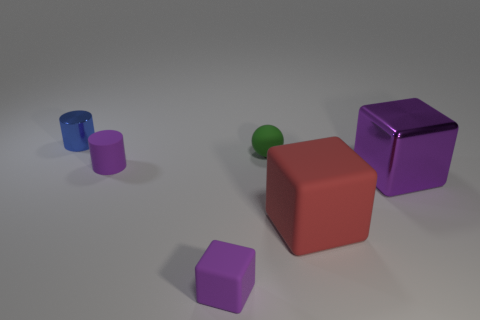Subtract all matte cubes. How many cubes are left? 1 Add 2 blue matte cylinders. How many objects exist? 8 Subtract 2 blocks. How many blocks are left? 1 Subtract all brown cylinders. How many purple cubes are left? 2 Subtract all blue cylinders. How many cylinders are left? 1 Subtract all cylinders. How many objects are left? 4 Add 1 small purple things. How many small purple things are left? 3 Add 2 big things. How many big things exist? 4 Subtract 1 blue cylinders. How many objects are left? 5 Subtract all yellow blocks. Subtract all green spheres. How many blocks are left? 3 